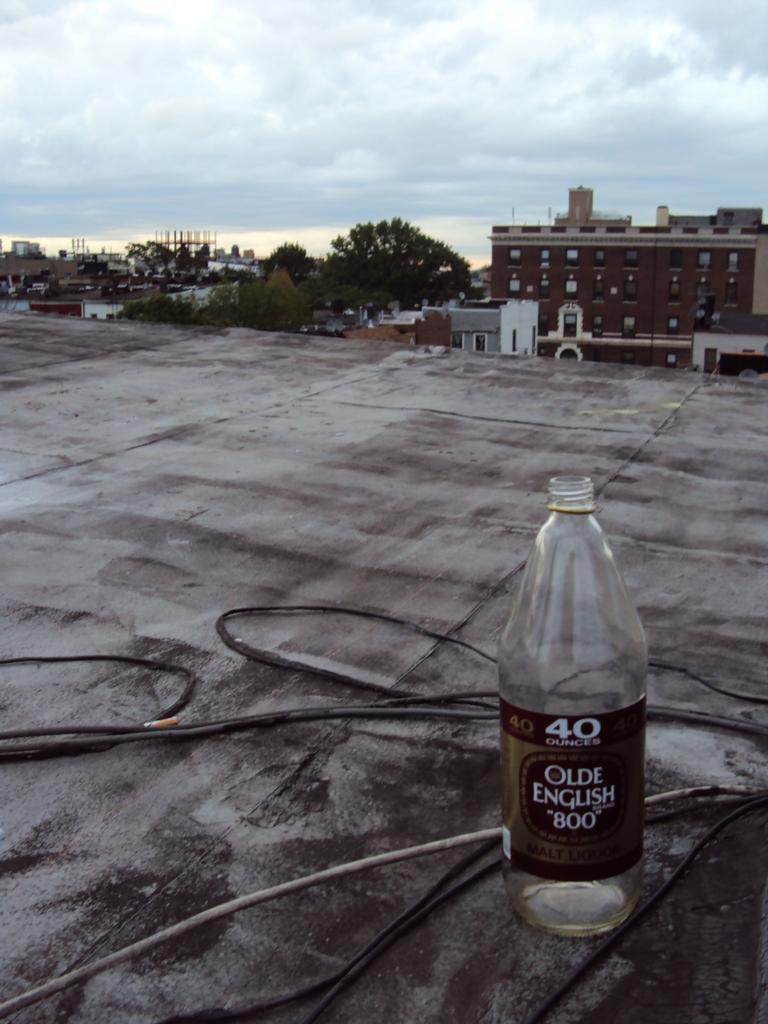<image>
Render a clear and concise summary of the photo. Bottle of Olde English Brand 800 beer on top of a building. 